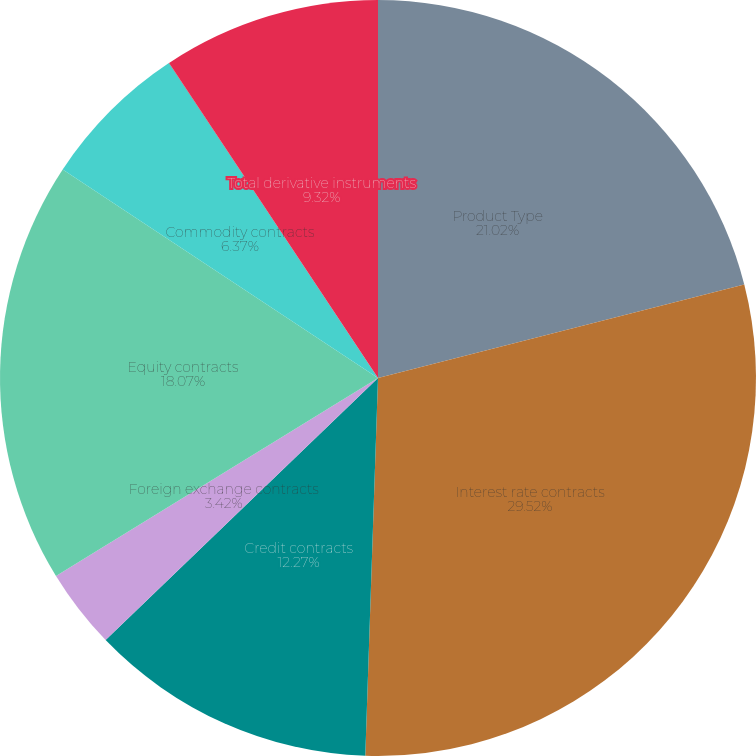<chart> <loc_0><loc_0><loc_500><loc_500><pie_chart><fcel>Product Type<fcel>Interest rate contracts<fcel>Credit contracts<fcel>Foreign exchange contracts<fcel>Equity contracts<fcel>Commodity contracts<fcel>Other contracts<fcel>Total derivative instruments<nl><fcel>21.02%<fcel>29.51%<fcel>12.27%<fcel>3.42%<fcel>18.07%<fcel>6.37%<fcel>0.01%<fcel>9.32%<nl></chart> 